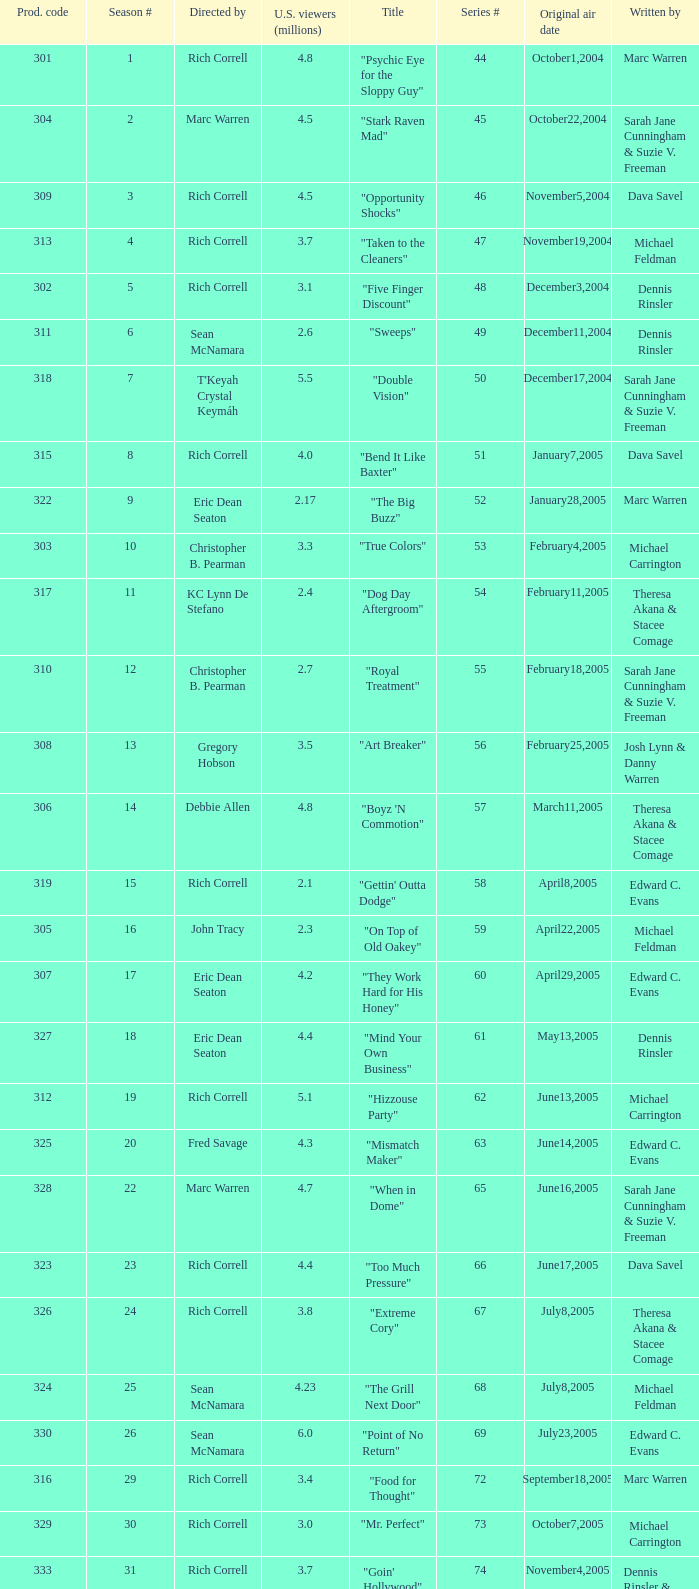What was the production code of the episode directed by Rondell Sheridan?  332.0. 